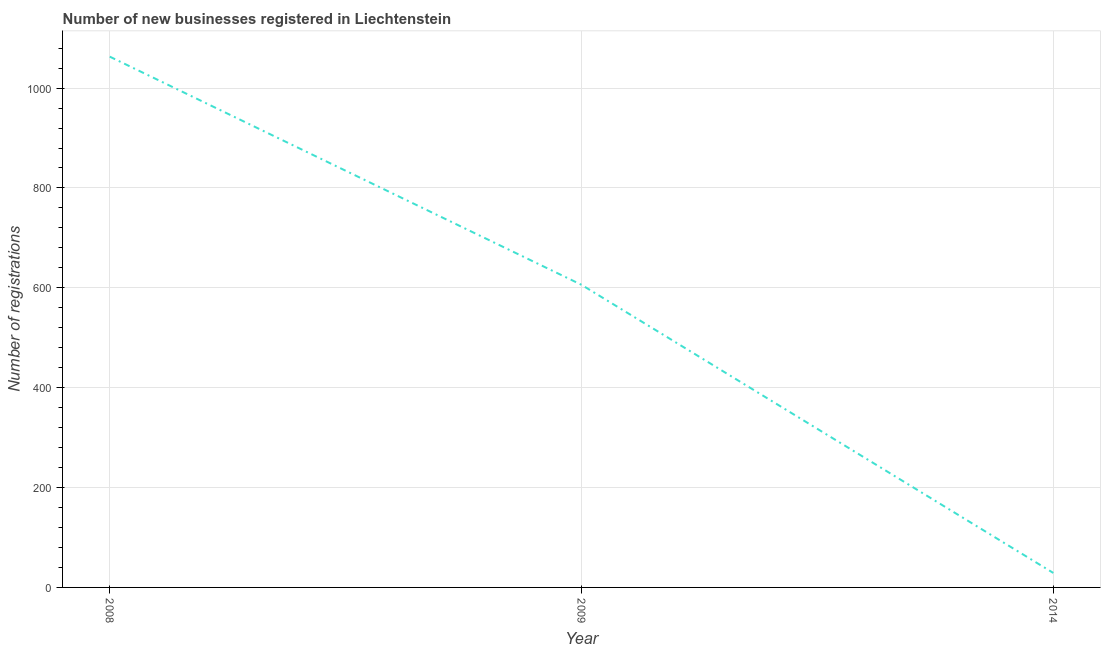What is the number of new business registrations in 2014?
Keep it short and to the point. 29. Across all years, what is the maximum number of new business registrations?
Provide a succinct answer. 1063. Across all years, what is the minimum number of new business registrations?
Offer a very short reply. 29. In which year was the number of new business registrations maximum?
Make the answer very short. 2008. What is the sum of the number of new business registrations?
Ensure brevity in your answer.  1698. What is the difference between the number of new business registrations in 2008 and 2009?
Offer a terse response. 457. What is the average number of new business registrations per year?
Keep it short and to the point. 566. What is the median number of new business registrations?
Offer a terse response. 606. What is the ratio of the number of new business registrations in 2008 to that in 2009?
Ensure brevity in your answer.  1.75. Is the number of new business registrations in 2009 less than that in 2014?
Ensure brevity in your answer.  No. What is the difference between the highest and the second highest number of new business registrations?
Your answer should be very brief. 457. Is the sum of the number of new business registrations in 2008 and 2014 greater than the maximum number of new business registrations across all years?
Provide a short and direct response. Yes. What is the difference between the highest and the lowest number of new business registrations?
Ensure brevity in your answer.  1034. In how many years, is the number of new business registrations greater than the average number of new business registrations taken over all years?
Offer a terse response. 2. Are the values on the major ticks of Y-axis written in scientific E-notation?
Your response must be concise. No. Does the graph contain any zero values?
Provide a short and direct response. No. What is the title of the graph?
Provide a succinct answer. Number of new businesses registered in Liechtenstein. What is the label or title of the Y-axis?
Offer a very short reply. Number of registrations. What is the Number of registrations in 2008?
Ensure brevity in your answer.  1063. What is the Number of registrations of 2009?
Offer a terse response. 606. What is the difference between the Number of registrations in 2008 and 2009?
Your response must be concise. 457. What is the difference between the Number of registrations in 2008 and 2014?
Provide a short and direct response. 1034. What is the difference between the Number of registrations in 2009 and 2014?
Ensure brevity in your answer.  577. What is the ratio of the Number of registrations in 2008 to that in 2009?
Ensure brevity in your answer.  1.75. What is the ratio of the Number of registrations in 2008 to that in 2014?
Make the answer very short. 36.66. What is the ratio of the Number of registrations in 2009 to that in 2014?
Make the answer very short. 20.9. 